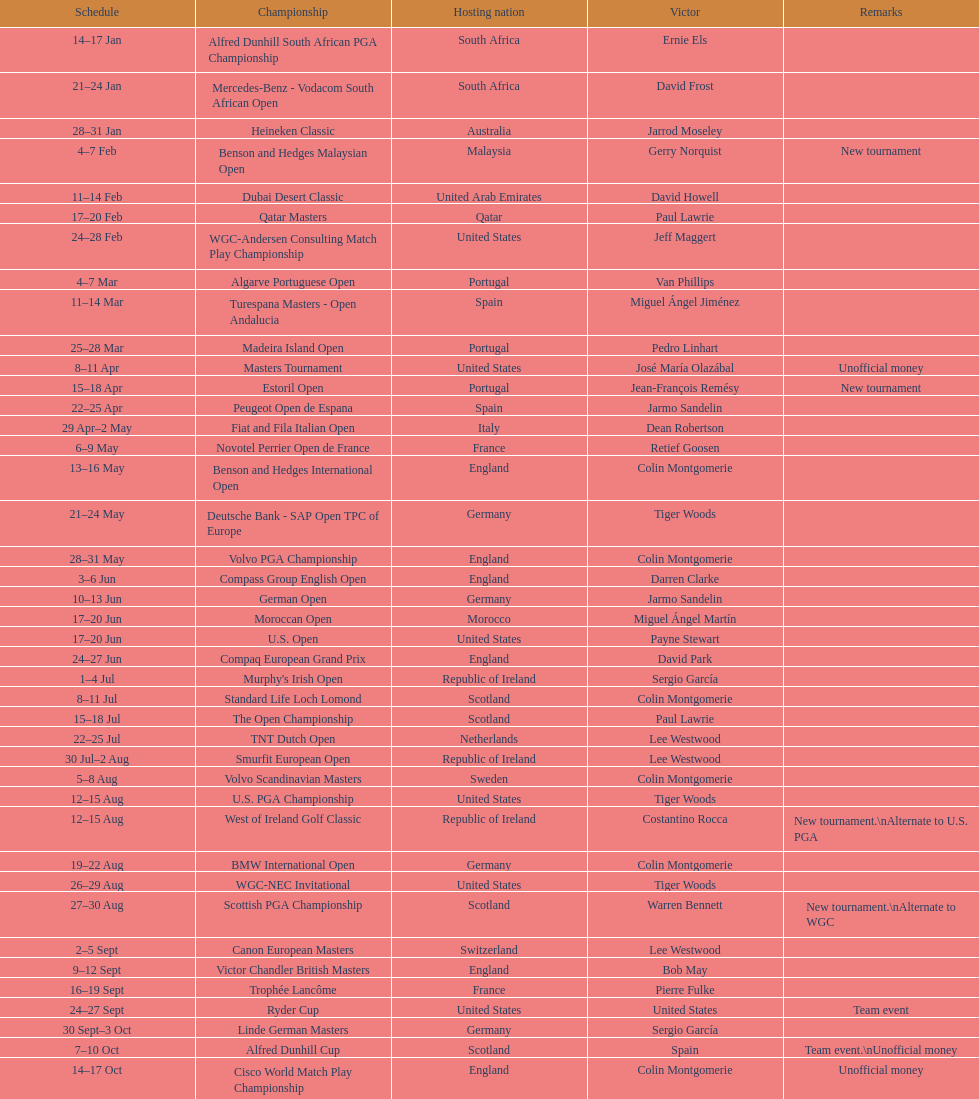What was the country listed the first time there was a new tournament? Malaysia. 